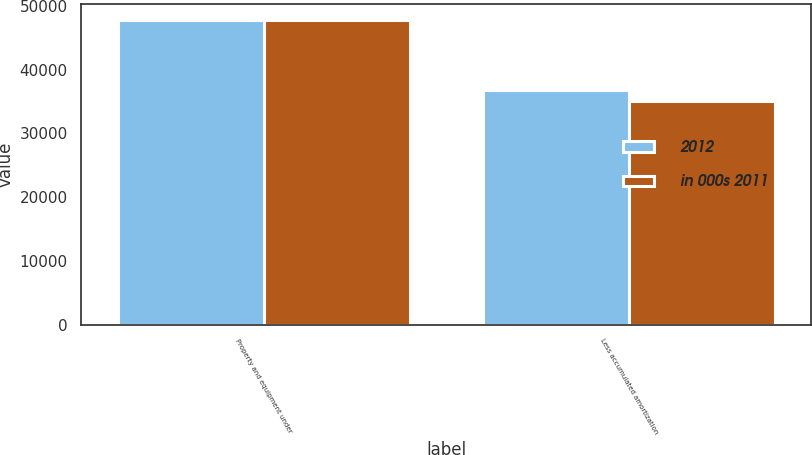<chart> <loc_0><loc_0><loc_500><loc_500><stacked_bar_chart><ecel><fcel>Property and equipment under<fcel>Less accumulated amortization<nl><fcel>2012<fcel>47842<fcel>36740<nl><fcel>in 000s 2011<fcel>47842<fcel>35056<nl></chart> 